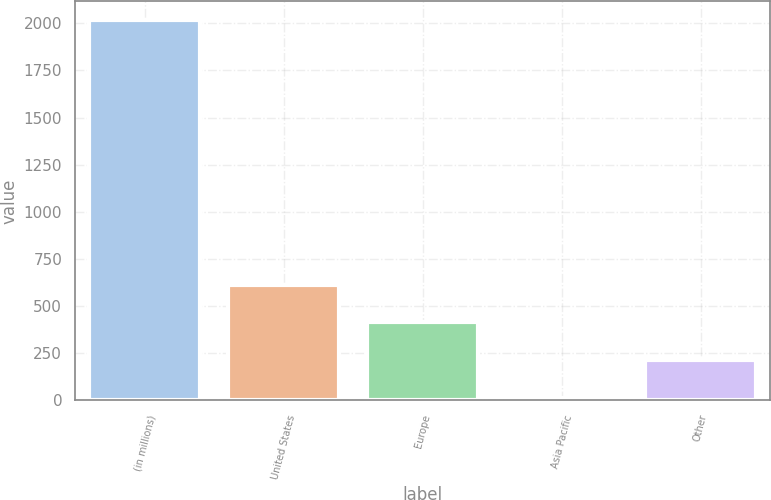Convert chart to OTSL. <chart><loc_0><loc_0><loc_500><loc_500><bar_chart><fcel>(in millions)<fcel>United States<fcel>Europe<fcel>Asia Pacific<fcel>Other<nl><fcel>2015<fcel>613.6<fcel>413.4<fcel>13<fcel>213.2<nl></chart> 